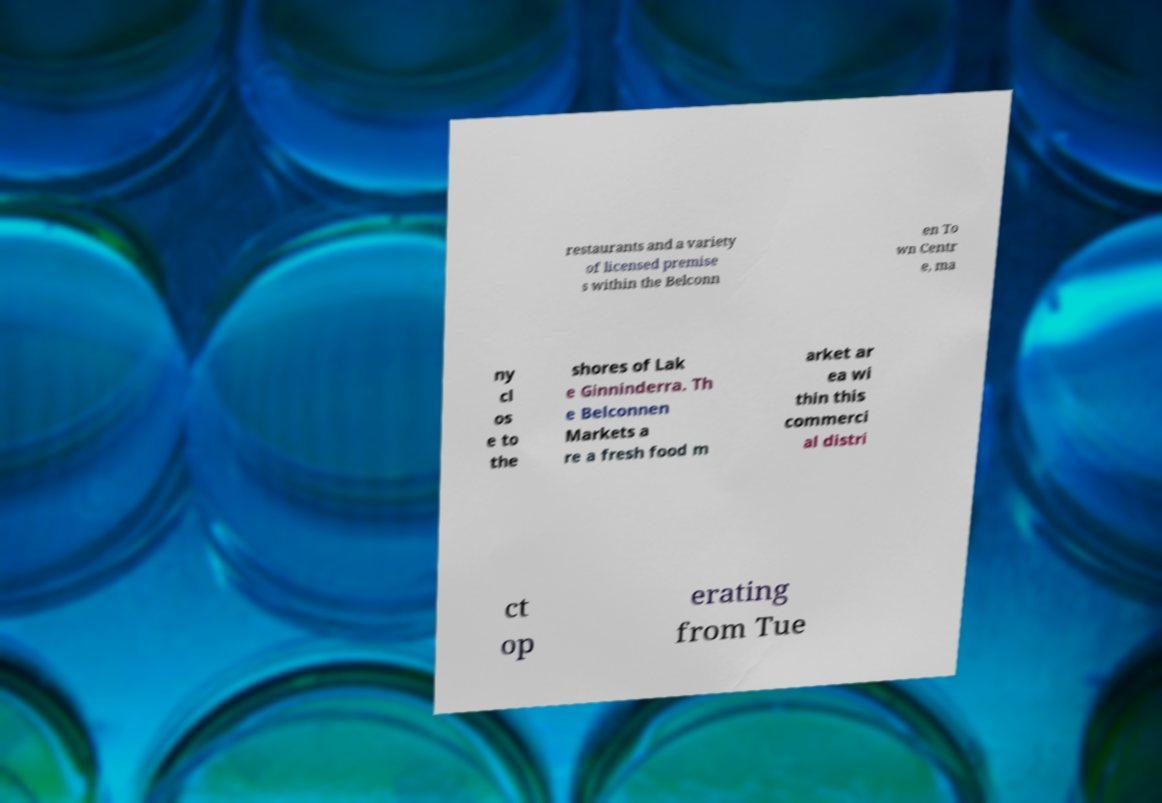For documentation purposes, I need the text within this image transcribed. Could you provide that? restaurants and a variety of licensed premise s within the Belconn en To wn Centr e, ma ny cl os e to the shores of Lak e Ginninderra. Th e Belconnen Markets a re a fresh food m arket ar ea wi thin this commerci al distri ct op erating from Tue 